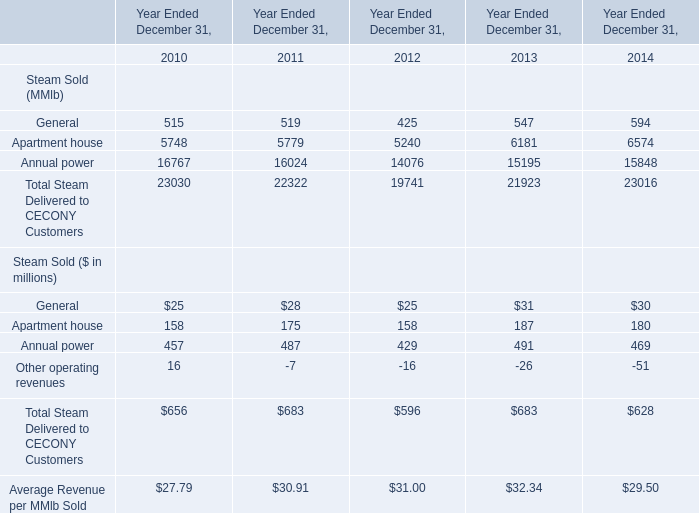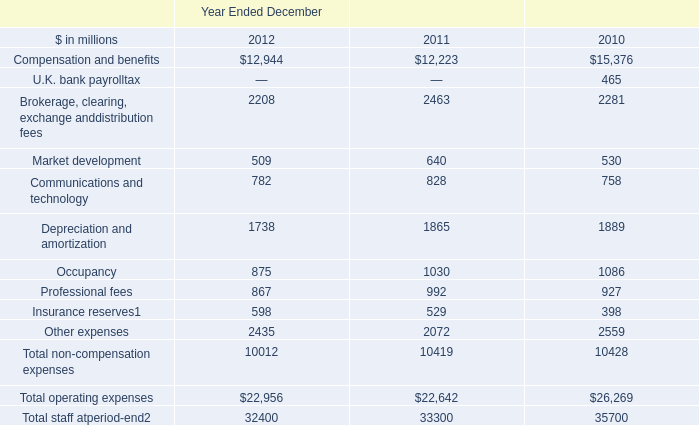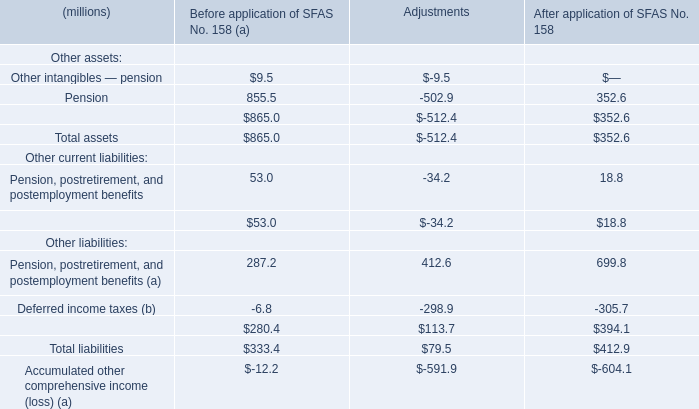What's the sum of all Steam Sold that are greater than 100 million in 2010? (in million) 
Computations: (158 + 457)
Answer: 615.0. 